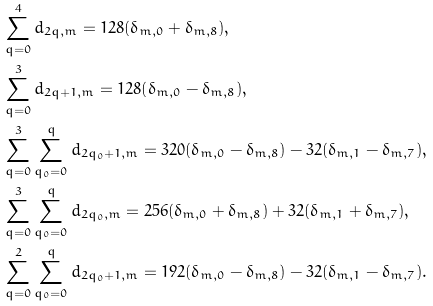<formula> <loc_0><loc_0><loc_500><loc_500>& \sum _ { q = 0 } ^ { 4 } d _ { 2 q , m } = 1 2 8 ( \delta _ { m , 0 } + \delta _ { m , 8 } ) , \\ & \sum _ { q = 0 } ^ { 3 } d _ { 2 q + 1 , m } = 1 2 8 ( \delta _ { m , 0 } - \delta _ { m , 8 } ) , \\ & \sum _ { q = 0 } ^ { 3 } \sum _ { q _ { 0 } = 0 } ^ { q } d _ { 2 q _ { 0 } + 1 , m } = 3 2 0 ( \delta _ { m , 0 } - \delta _ { m , 8 } ) - 3 2 ( \delta _ { m , 1 } - \delta _ { m , 7 } ) , \\ & \sum _ { q = 0 } ^ { 3 } \sum _ { q _ { 0 } = 0 } ^ { q } d _ { 2 q _ { 0 } , m } = 2 5 6 ( \delta _ { m , 0 } + \delta _ { m , 8 } ) + 3 2 ( \delta _ { m , 1 } + \delta _ { m , 7 } ) , \\ & \sum _ { q = 0 } ^ { 2 } \sum _ { q _ { 0 } = 0 } ^ { q } d _ { 2 q _ { 0 } + 1 , m } = 1 9 2 ( \delta _ { m , 0 } - \delta _ { m , 8 } ) - 3 2 ( \delta _ { m , 1 } - \delta _ { m , 7 } ) .</formula> 